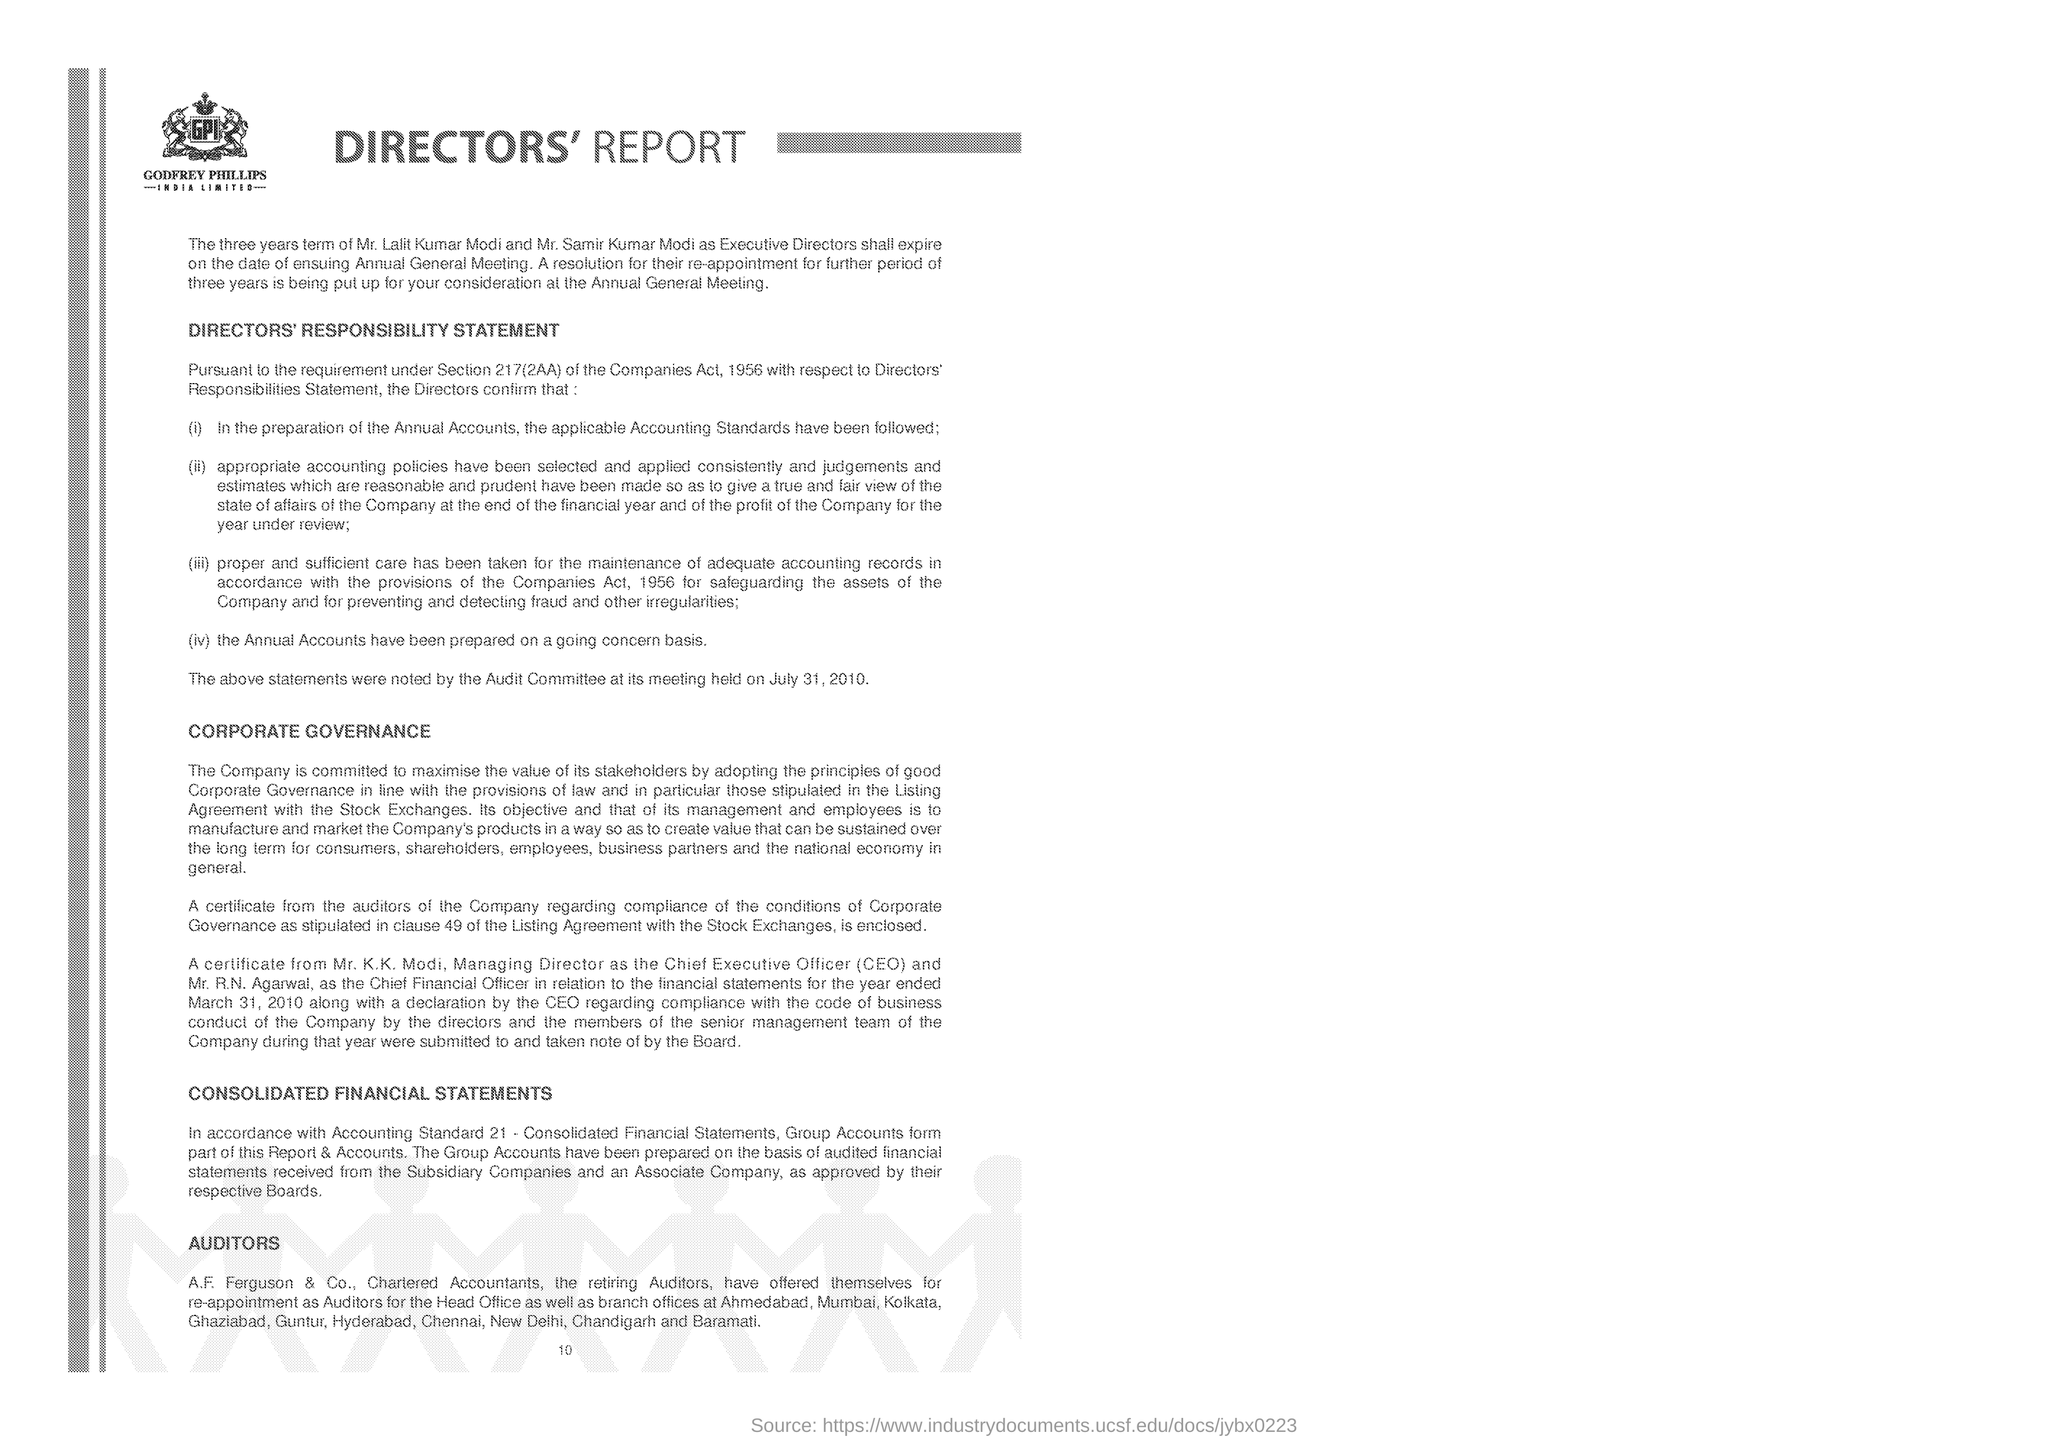Outline some significant characteristics in this image. The document mentions Godfrey Phillips as a company. 